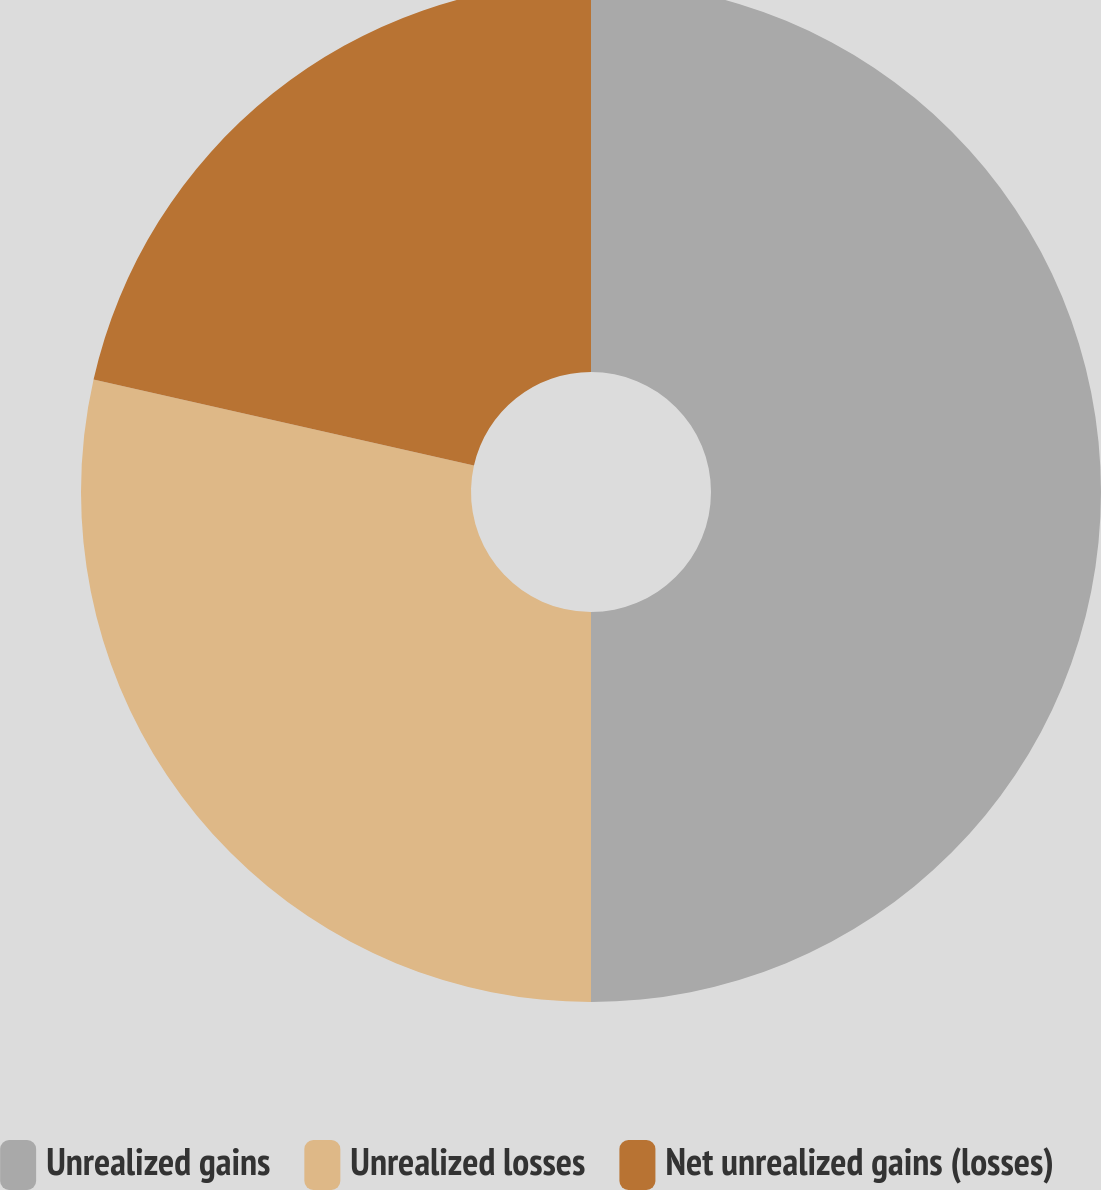Convert chart. <chart><loc_0><loc_0><loc_500><loc_500><pie_chart><fcel>Unrealized gains<fcel>Unrealized losses<fcel>Net unrealized gains (losses)<nl><fcel>50.0%<fcel>28.54%<fcel>21.46%<nl></chart> 